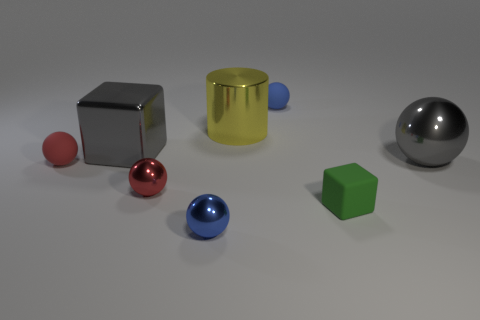Is there a large yellow metal cylinder?
Offer a very short reply. Yes. What is the size of the ball that is both in front of the yellow metallic thing and on the right side of the big yellow metal cylinder?
Ensure brevity in your answer.  Large. The big yellow thing has what shape?
Your response must be concise. Cylinder. Is there a yellow cylinder that is behind the tiny blue object that is behind the small green block?
Your answer should be very brief. No. What material is the gray cube that is the same size as the gray sphere?
Offer a terse response. Metal. Is there a sphere that has the same size as the shiny block?
Ensure brevity in your answer.  Yes. There is a cube that is to the right of the metal cube; what is its material?
Your answer should be compact. Rubber. Is the gray object on the right side of the large yellow metal cylinder made of the same material as the large yellow object?
Offer a very short reply. Yes. There is a blue metal object that is the same size as the red matte sphere; what is its shape?
Your response must be concise. Sphere. How many matte cylinders have the same color as the large metal cube?
Your response must be concise. 0. 